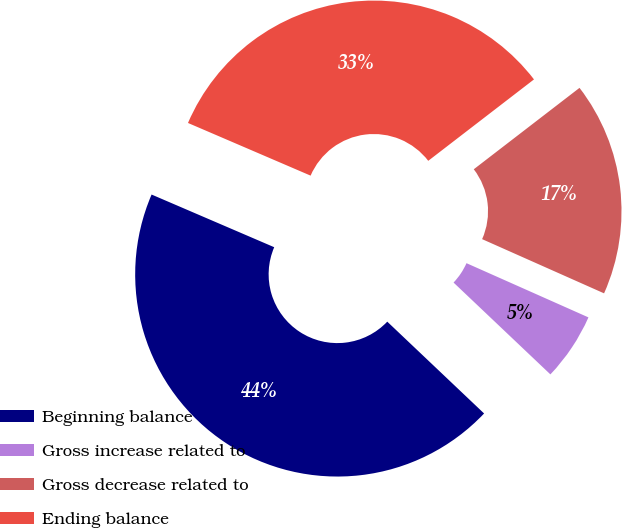Convert chart to OTSL. <chart><loc_0><loc_0><loc_500><loc_500><pie_chart><fcel>Beginning balance<fcel>Gross increase related to<fcel>Gross decrease related to<fcel>Ending balance<nl><fcel>44.38%<fcel>5.42%<fcel>17.1%<fcel>33.1%<nl></chart> 